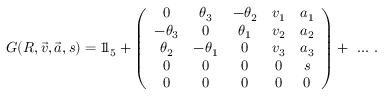Convert formula to latex. <formula><loc_0><loc_0><loc_500><loc_500>G ( R , { \vec { v } } , { \vec { a } } , s ) = 1 \, 1 _ { 5 } + \left ( { \begin{array} { c c c c c } { 0 } & { \theta _ { 3 } } & { - \theta _ { 2 } } & { v _ { 1 } } & { a _ { 1 } } \\ { - \theta _ { 3 } } & { 0 } & { \theta _ { 1 } } & { v _ { 2 } } & { a _ { 2 } } \\ { \theta _ { 2 } } & { - \theta _ { 1 } } & { 0 } & { v _ { 3 } } & { a _ { 3 } } \\ { 0 } & { 0 } & { 0 } & { 0 } & { s } \\ { 0 } & { 0 } & { 0 } & { 0 } & { 0 } \end{array} } \right ) + \ \dots .</formula> 